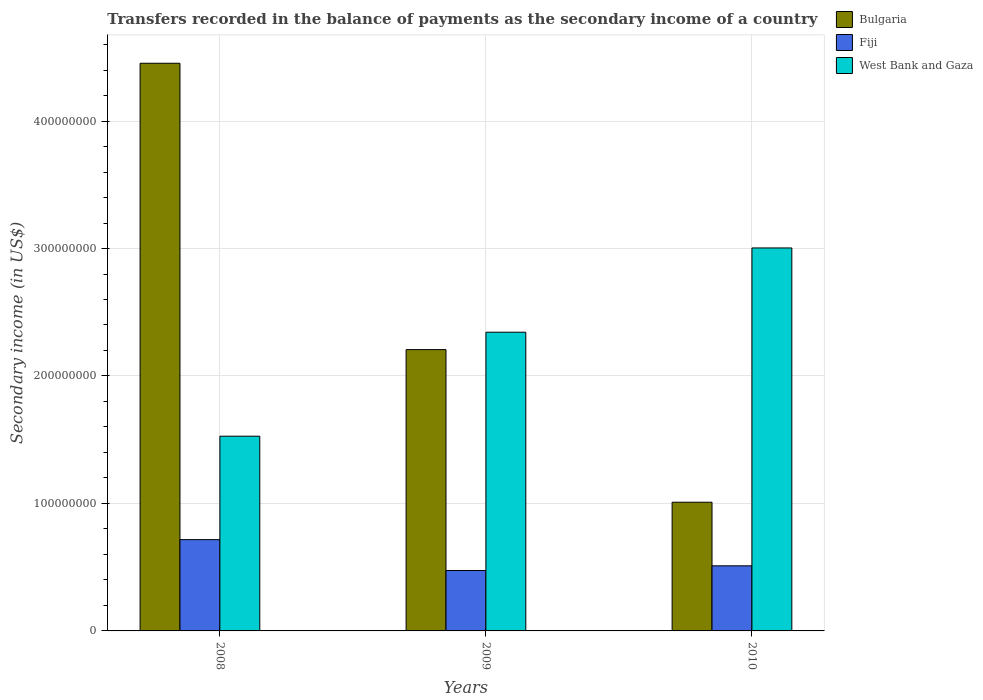How many different coloured bars are there?
Your answer should be very brief. 3. Are the number of bars per tick equal to the number of legend labels?
Offer a terse response. Yes. Are the number of bars on each tick of the X-axis equal?
Offer a very short reply. Yes. What is the secondary income of in Bulgaria in 2009?
Ensure brevity in your answer.  2.21e+08. Across all years, what is the maximum secondary income of in Bulgaria?
Your answer should be very brief. 4.45e+08. Across all years, what is the minimum secondary income of in West Bank and Gaza?
Your answer should be very brief. 1.53e+08. In which year was the secondary income of in West Bank and Gaza minimum?
Your response must be concise. 2008. What is the total secondary income of in West Bank and Gaza in the graph?
Provide a short and direct response. 6.88e+08. What is the difference between the secondary income of in West Bank and Gaza in 2008 and that in 2010?
Your response must be concise. -1.48e+08. What is the difference between the secondary income of in West Bank and Gaza in 2010 and the secondary income of in Bulgaria in 2009?
Your answer should be very brief. 7.98e+07. What is the average secondary income of in Fiji per year?
Your answer should be compact. 5.67e+07. In the year 2008, what is the difference between the secondary income of in Bulgaria and secondary income of in West Bank and Gaza?
Your answer should be very brief. 2.93e+08. In how many years, is the secondary income of in Fiji greater than 220000000 US$?
Your answer should be compact. 0. What is the ratio of the secondary income of in Bulgaria in 2008 to that in 2009?
Your answer should be very brief. 2.02. What is the difference between the highest and the second highest secondary income of in Fiji?
Give a very brief answer. 2.05e+07. What is the difference between the highest and the lowest secondary income of in Bulgaria?
Your response must be concise. 3.44e+08. What does the 3rd bar from the left in 2008 represents?
Offer a terse response. West Bank and Gaza. What does the 2nd bar from the right in 2008 represents?
Give a very brief answer. Fiji. Is it the case that in every year, the sum of the secondary income of in Fiji and secondary income of in Bulgaria is greater than the secondary income of in West Bank and Gaza?
Your response must be concise. No. How many years are there in the graph?
Your answer should be compact. 3. What is the difference between two consecutive major ticks on the Y-axis?
Your answer should be compact. 1.00e+08. Are the values on the major ticks of Y-axis written in scientific E-notation?
Give a very brief answer. No. Does the graph contain any zero values?
Offer a terse response. No. How are the legend labels stacked?
Keep it short and to the point. Vertical. What is the title of the graph?
Offer a terse response. Transfers recorded in the balance of payments as the secondary income of a country. What is the label or title of the Y-axis?
Your answer should be very brief. Secondary income (in US$). What is the Secondary income (in US$) in Bulgaria in 2008?
Give a very brief answer. 4.45e+08. What is the Secondary income (in US$) in Fiji in 2008?
Your answer should be very brief. 7.16e+07. What is the Secondary income (in US$) in West Bank and Gaza in 2008?
Your answer should be very brief. 1.53e+08. What is the Secondary income (in US$) in Bulgaria in 2009?
Ensure brevity in your answer.  2.21e+08. What is the Secondary income (in US$) in Fiji in 2009?
Your answer should be very brief. 4.74e+07. What is the Secondary income (in US$) in West Bank and Gaza in 2009?
Keep it short and to the point. 2.34e+08. What is the Secondary income (in US$) of Bulgaria in 2010?
Offer a very short reply. 1.01e+08. What is the Secondary income (in US$) in Fiji in 2010?
Provide a short and direct response. 5.11e+07. What is the Secondary income (in US$) of West Bank and Gaza in 2010?
Give a very brief answer. 3.00e+08. Across all years, what is the maximum Secondary income (in US$) of Bulgaria?
Provide a short and direct response. 4.45e+08. Across all years, what is the maximum Secondary income (in US$) in Fiji?
Your answer should be compact. 7.16e+07. Across all years, what is the maximum Secondary income (in US$) of West Bank and Gaza?
Your answer should be compact. 3.00e+08. Across all years, what is the minimum Secondary income (in US$) in Bulgaria?
Give a very brief answer. 1.01e+08. Across all years, what is the minimum Secondary income (in US$) in Fiji?
Keep it short and to the point. 4.74e+07. Across all years, what is the minimum Secondary income (in US$) in West Bank and Gaza?
Your answer should be very brief. 1.53e+08. What is the total Secondary income (in US$) of Bulgaria in the graph?
Provide a succinct answer. 7.67e+08. What is the total Secondary income (in US$) in Fiji in the graph?
Provide a succinct answer. 1.70e+08. What is the total Secondary income (in US$) in West Bank and Gaza in the graph?
Keep it short and to the point. 6.88e+08. What is the difference between the Secondary income (in US$) in Bulgaria in 2008 and that in 2009?
Your response must be concise. 2.25e+08. What is the difference between the Secondary income (in US$) in Fiji in 2008 and that in 2009?
Keep it short and to the point. 2.42e+07. What is the difference between the Secondary income (in US$) of West Bank and Gaza in 2008 and that in 2009?
Offer a very short reply. -8.16e+07. What is the difference between the Secondary income (in US$) in Bulgaria in 2008 and that in 2010?
Ensure brevity in your answer.  3.44e+08. What is the difference between the Secondary income (in US$) in Fiji in 2008 and that in 2010?
Your answer should be very brief. 2.05e+07. What is the difference between the Secondary income (in US$) of West Bank and Gaza in 2008 and that in 2010?
Offer a very short reply. -1.48e+08. What is the difference between the Secondary income (in US$) in Bulgaria in 2009 and that in 2010?
Your answer should be very brief. 1.20e+08. What is the difference between the Secondary income (in US$) in Fiji in 2009 and that in 2010?
Offer a terse response. -3.69e+06. What is the difference between the Secondary income (in US$) in West Bank and Gaza in 2009 and that in 2010?
Provide a short and direct response. -6.61e+07. What is the difference between the Secondary income (in US$) of Bulgaria in 2008 and the Secondary income (in US$) of Fiji in 2009?
Make the answer very short. 3.98e+08. What is the difference between the Secondary income (in US$) of Bulgaria in 2008 and the Secondary income (in US$) of West Bank and Gaza in 2009?
Provide a succinct answer. 2.11e+08. What is the difference between the Secondary income (in US$) in Fiji in 2008 and the Secondary income (in US$) in West Bank and Gaza in 2009?
Keep it short and to the point. -1.63e+08. What is the difference between the Secondary income (in US$) in Bulgaria in 2008 and the Secondary income (in US$) in Fiji in 2010?
Ensure brevity in your answer.  3.94e+08. What is the difference between the Secondary income (in US$) in Bulgaria in 2008 and the Secondary income (in US$) in West Bank and Gaza in 2010?
Make the answer very short. 1.45e+08. What is the difference between the Secondary income (in US$) of Fiji in 2008 and the Secondary income (in US$) of West Bank and Gaza in 2010?
Your response must be concise. -2.29e+08. What is the difference between the Secondary income (in US$) of Bulgaria in 2009 and the Secondary income (in US$) of Fiji in 2010?
Your answer should be compact. 1.70e+08. What is the difference between the Secondary income (in US$) of Bulgaria in 2009 and the Secondary income (in US$) of West Bank and Gaza in 2010?
Keep it short and to the point. -7.98e+07. What is the difference between the Secondary income (in US$) of Fiji in 2009 and the Secondary income (in US$) of West Bank and Gaza in 2010?
Provide a succinct answer. -2.53e+08. What is the average Secondary income (in US$) of Bulgaria per year?
Make the answer very short. 2.56e+08. What is the average Secondary income (in US$) in Fiji per year?
Make the answer very short. 5.67e+07. What is the average Secondary income (in US$) in West Bank and Gaza per year?
Make the answer very short. 2.29e+08. In the year 2008, what is the difference between the Secondary income (in US$) in Bulgaria and Secondary income (in US$) in Fiji?
Provide a succinct answer. 3.74e+08. In the year 2008, what is the difference between the Secondary income (in US$) in Bulgaria and Secondary income (in US$) in West Bank and Gaza?
Provide a succinct answer. 2.93e+08. In the year 2008, what is the difference between the Secondary income (in US$) of Fiji and Secondary income (in US$) of West Bank and Gaza?
Provide a short and direct response. -8.12e+07. In the year 2009, what is the difference between the Secondary income (in US$) of Bulgaria and Secondary income (in US$) of Fiji?
Your response must be concise. 1.73e+08. In the year 2009, what is the difference between the Secondary income (in US$) in Bulgaria and Secondary income (in US$) in West Bank and Gaza?
Offer a terse response. -1.36e+07. In the year 2009, what is the difference between the Secondary income (in US$) in Fiji and Secondary income (in US$) in West Bank and Gaza?
Your answer should be very brief. -1.87e+08. In the year 2010, what is the difference between the Secondary income (in US$) in Bulgaria and Secondary income (in US$) in Fiji?
Offer a very short reply. 4.99e+07. In the year 2010, what is the difference between the Secondary income (in US$) in Bulgaria and Secondary income (in US$) in West Bank and Gaza?
Provide a succinct answer. -1.99e+08. In the year 2010, what is the difference between the Secondary income (in US$) of Fiji and Secondary income (in US$) of West Bank and Gaza?
Provide a short and direct response. -2.49e+08. What is the ratio of the Secondary income (in US$) of Bulgaria in 2008 to that in 2009?
Provide a succinct answer. 2.02. What is the ratio of the Secondary income (in US$) of Fiji in 2008 to that in 2009?
Offer a terse response. 1.51. What is the ratio of the Secondary income (in US$) of West Bank and Gaza in 2008 to that in 2009?
Give a very brief answer. 0.65. What is the ratio of the Secondary income (in US$) in Bulgaria in 2008 to that in 2010?
Give a very brief answer. 4.41. What is the ratio of the Secondary income (in US$) of Fiji in 2008 to that in 2010?
Offer a terse response. 1.4. What is the ratio of the Secondary income (in US$) of West Bank and Gaza in 2008 to that in 2010?
Offer a very short reply. 0.51. What is the ratio of the Secondary income (in US$) of Bulgaria in 2009 to that in 2010?
Offer a very short reply. 2.19. What is the ratio of the Secondary income (in US$) in Fiji in 2009 to that in 2010?
Ensure brevity in your answer.  0.93. What is the ratio of the Secondary income (in US$) in West Bank and Gaza in 2009 to that in 2010?
Ensure brevity in your answer.  0.78. What is the difference between the highest and the second highest Secondary income (in US$) in Bulgaria?
Offer a terse response. 2.25e+08. What is the difference between the highest and the second highest Secondary income (in US$) in Fiji?
Provide a short and direct response. 2.05e+07. What is the difference between the highest and the second highest Secondary income (in US$) of West Bank and Gaza?
Keep it short and to the point. 6.61e+07. What is the difference between the highest and the lowest Secondary income (in US$) in Bulgaria?
Provide a short and direct response. 3.44e+08. What is the difference between the highest and the lowest Secondary income (in US$) of Fiji?
Provide a succinct answer. 2.42e+07. What is the difference between the highest and the lowest Secondary income (in US$) of West Bank and Gaza?
Your answer should be very brief. 1.48e+08. 